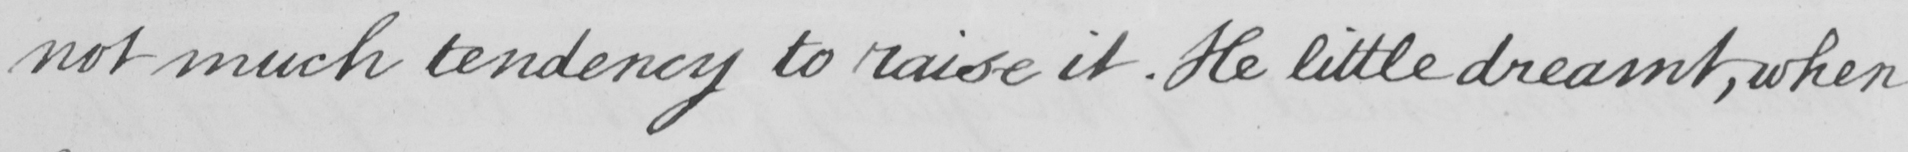Can you tell me what this handwritten text says? not much tendency to raise it . He little dreamt , when 